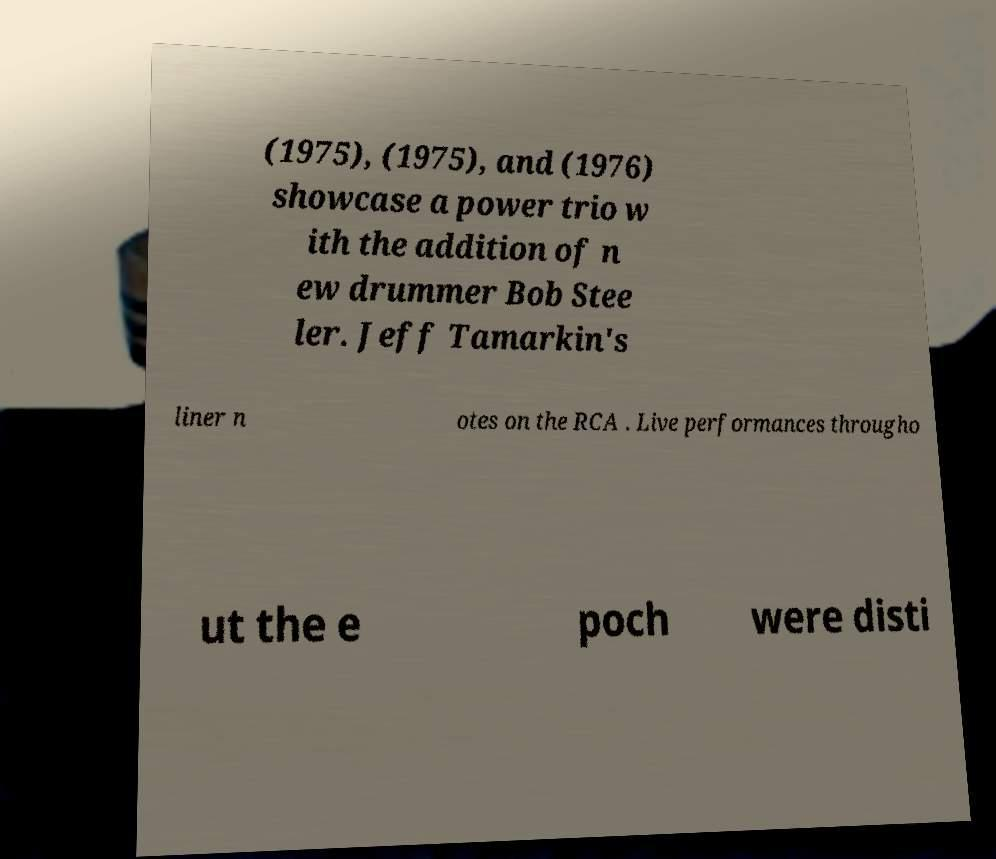Please read and relay the text visible in this image. What does it say? (1975), (1975), and (1976) showcase a power trio w ith the addition of n ew drummer Bob Stee ler. Jeff Tamarkin's liner n otes on the RCA . Live performances througho ut the e poch were disti 